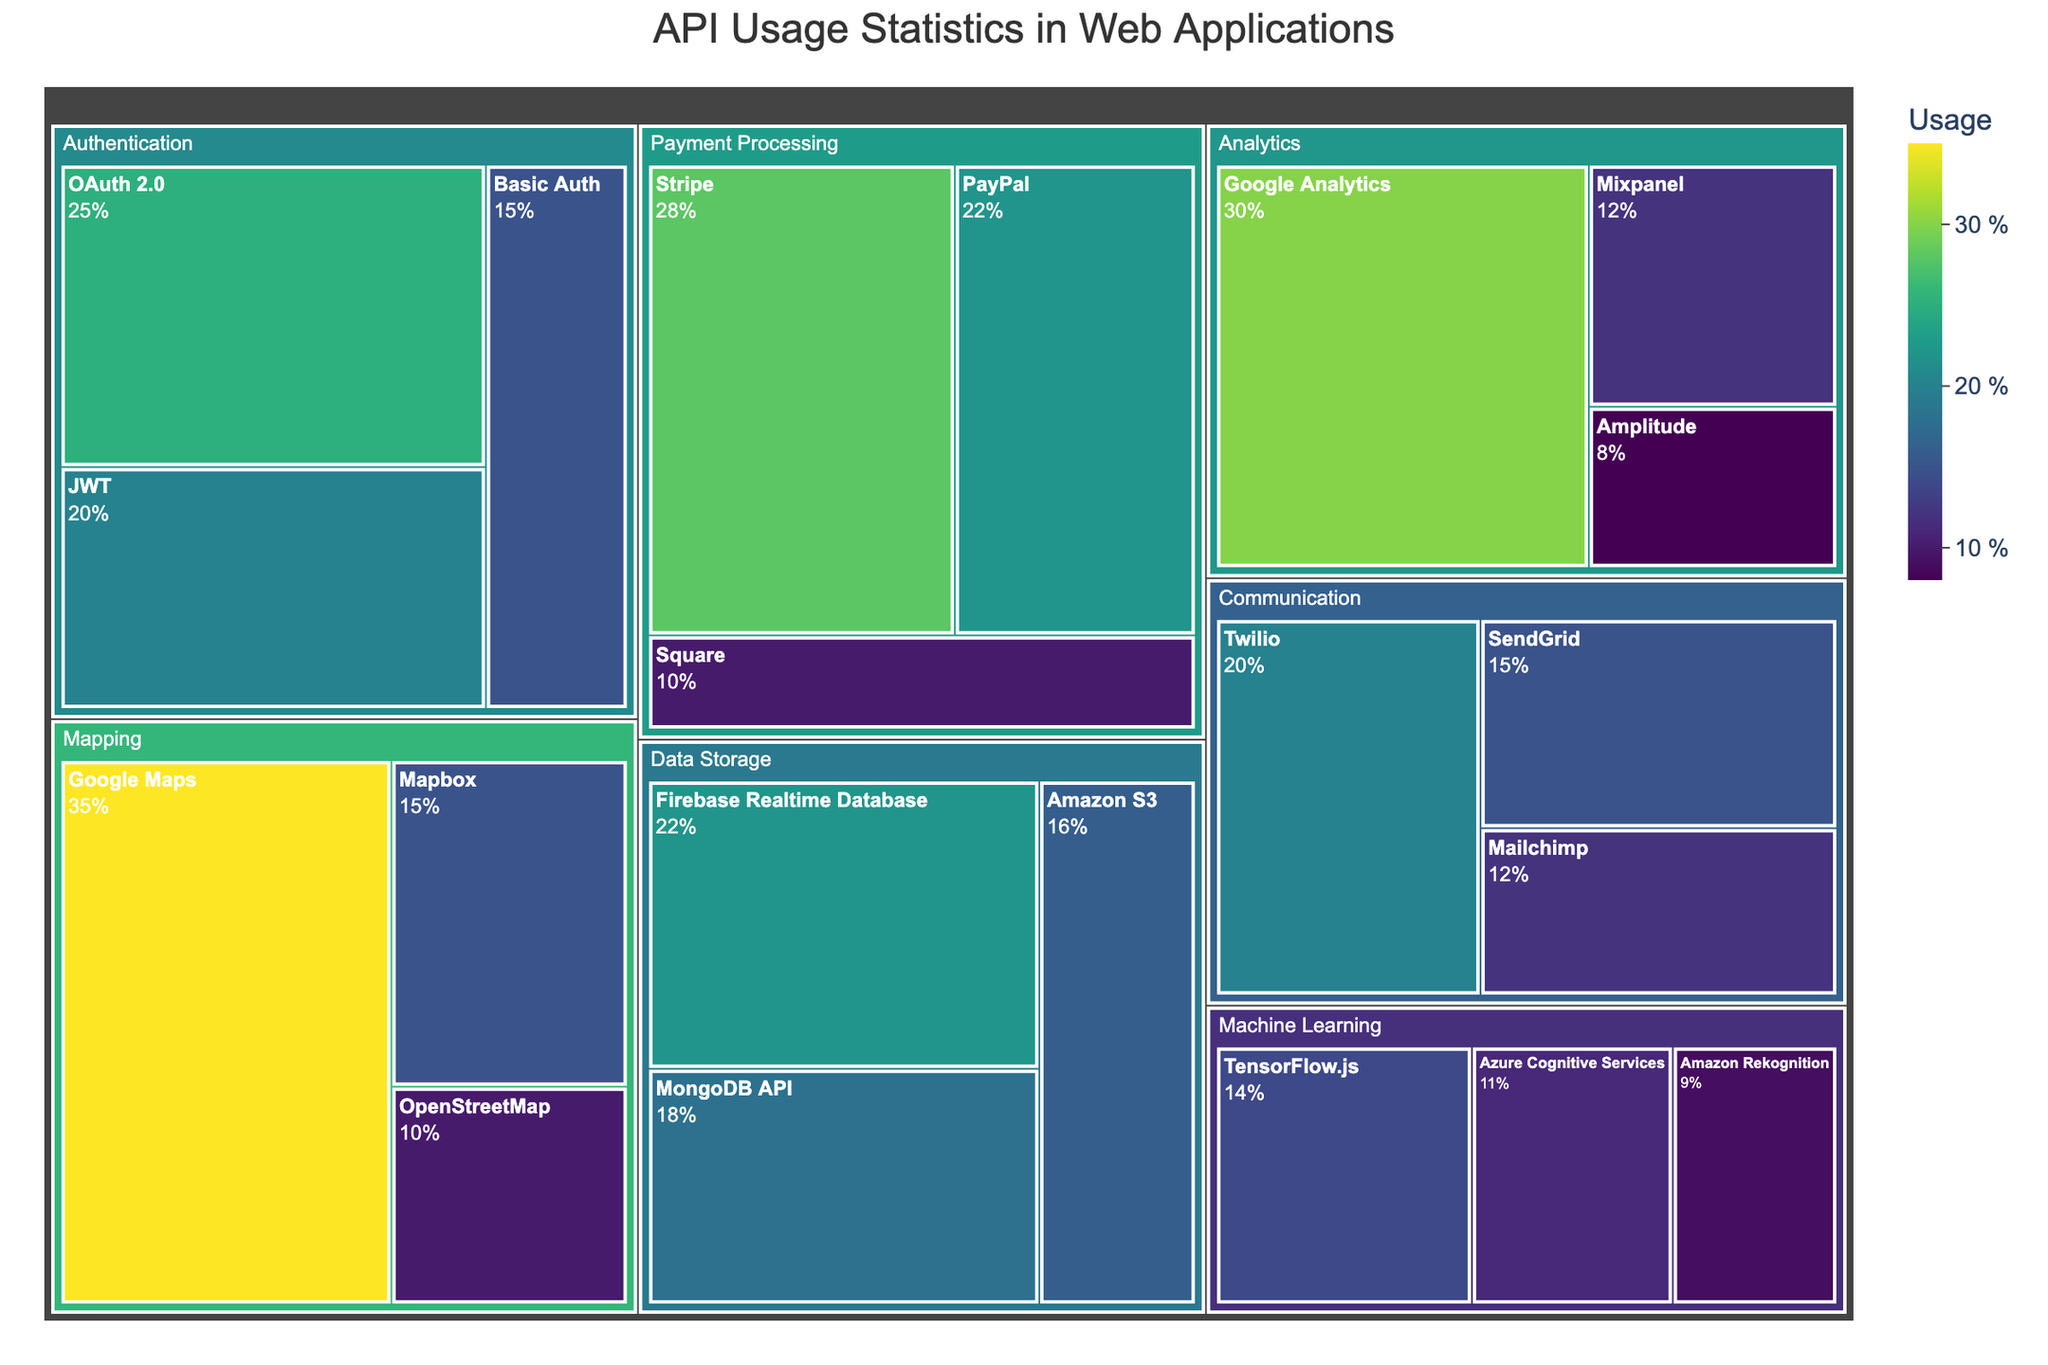What's the largest API usage category? By looking at the treemap's structure, the "Mapping" category has the largest tile, indicating the highest usage percentage.
Answer: Mapping Which subcategory has the highest usage percentage in "Authentication"? Within the "Authentication" category, the tile size indicates "OAuth 2.0" has the highest usage percentage.
Answer: OAuth 2.0 What is the total percentage of usage for the "Payment Processing" category? Summing up the values for Stripe (28), PayPal (22), and Square (10) gives 28 + 22 + 10 = 60.
Answer: 60 Compare the usage of Google Analytics and Mixpanel. Which one is higher? Google Analytics has a larger tile than Mixpanel in the "Analytics" category, indicating higher usage.
Answer: Google Analytics What's the total percentage usage for subcategories under the "Data Storage" category? Adding the usage percentages: MongoDB API (18), Firebase Realtime Database (22), and Amazon S3 (16) results in 18 + 22 + 16 = 56.
Answer: 56 Which API subcategory has the lowest usage percentage overall? Scanning the treemap, "Amazon Rekognition" under "Machine Learning" has the smallest tile, indicating the lowest usage at 9%.
Answer: Amazon Rekognition Compare the usage percentage between the top subcategories of "Communication" and "Analytics". Which is higher? Twilio in "Communication" has 20%, while Google Analytics in "Analytics" has 30%, making Google Analytics higher.
Answer: Google Analytics What's the average usage percentage of all subcategories under "Machine Learning"? The usage percentages are TensorFlow.js (14), Azure Cognitive Services (11), and Amazon Rekognition (9). The average is (14 + 11 + 9) / 3 = 11.33.
Answer: 11.33 How does the usage percentage of Google Maps compare to Twilio? Google Maps has a larger tile with 35% compared to Twilio's 20%.
Answer: Google Maps is higher What's the difference in usage percentage between the highest and lowest subcategories under "Authentication"? The highest is OAuth 2.0 (25%) and the lowest is Basic Auth (15%), the difference is 25 - 15 = 10.
Answer: 10 